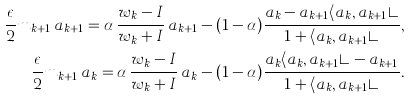Convert formula to latex. <formula><loc_0><loc_0><loc_500><loc_500>\frac { \epsilon } { 2 } m _ { k + 1 } \, a _ { k + 1 } = \alpha \, \frac { w _ { k } - I } { w _ { k } + I } \, a _ { k + 1 } - ( 1 - \alpha ) \frac { a _ { k } - a _ { k + 1 } \langle a _ { k } , a _ { k + 1 } \rangle } { 1 + \langle a _ { k } , a _ { k + 1 } \rangle } , \\ \frac { \epsilon } { 2 } m _ { k + 1 } \, a _ { k } = \alpha \, \frac { w _ { k } - I } { w _ { k } + I } \, a _ { k } - ( 1 - \alpha ) \frac { a _ { k } \langle a _ { k } , a _ { k + 1 } \rangle - a _ { k + 1 } } { 1 + \langle a _ { k } , a _ { k + 1 } \rangle } .</formula> 